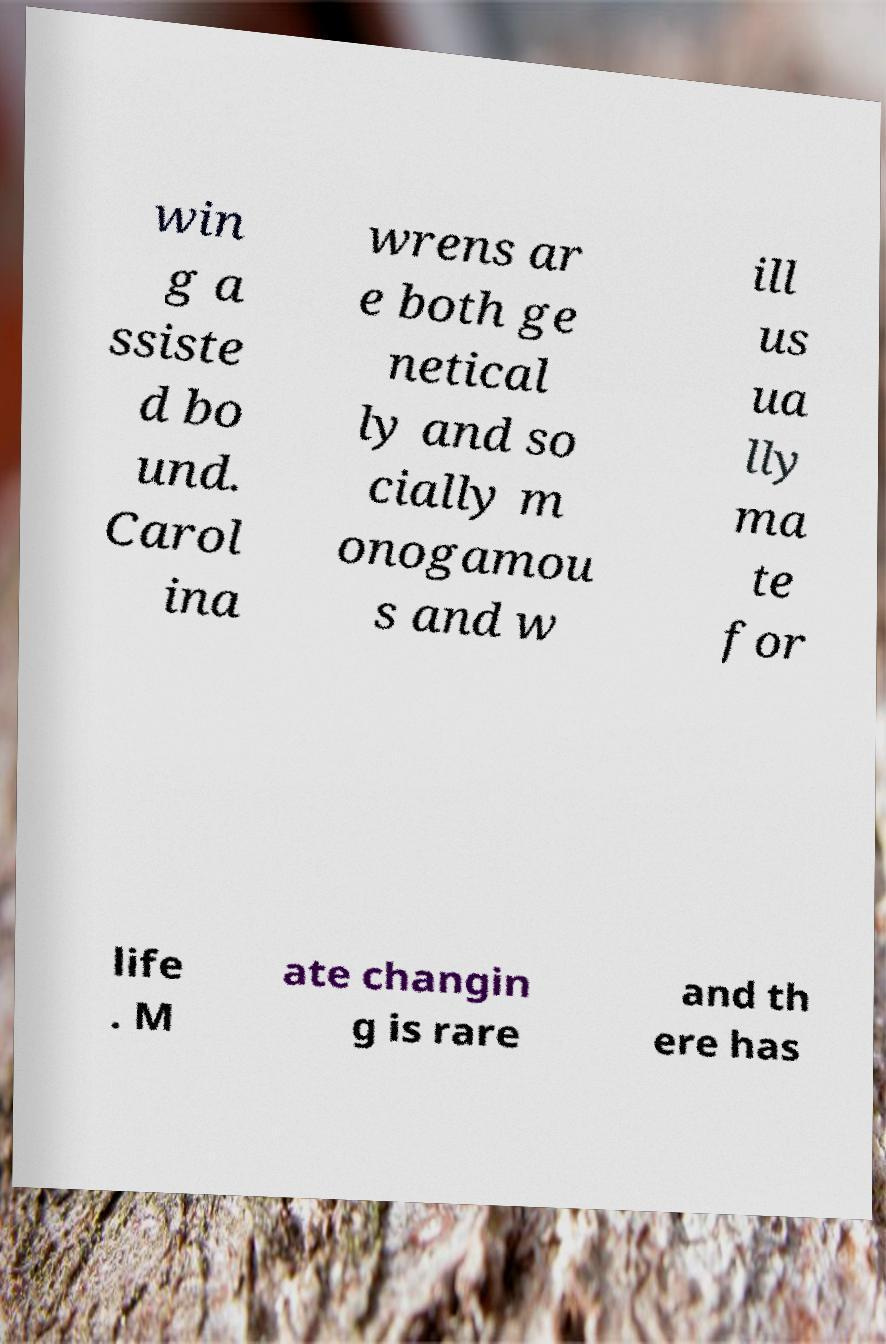What messages or text are displayed in this image? I need them in a readable, typed format. win g a ssiste d bo und. Carol ina wrens ar e both ge netical ly and so cially m onogamou s and w ill us ua lly ma te for life . M ate changin g is rare and th ere has 